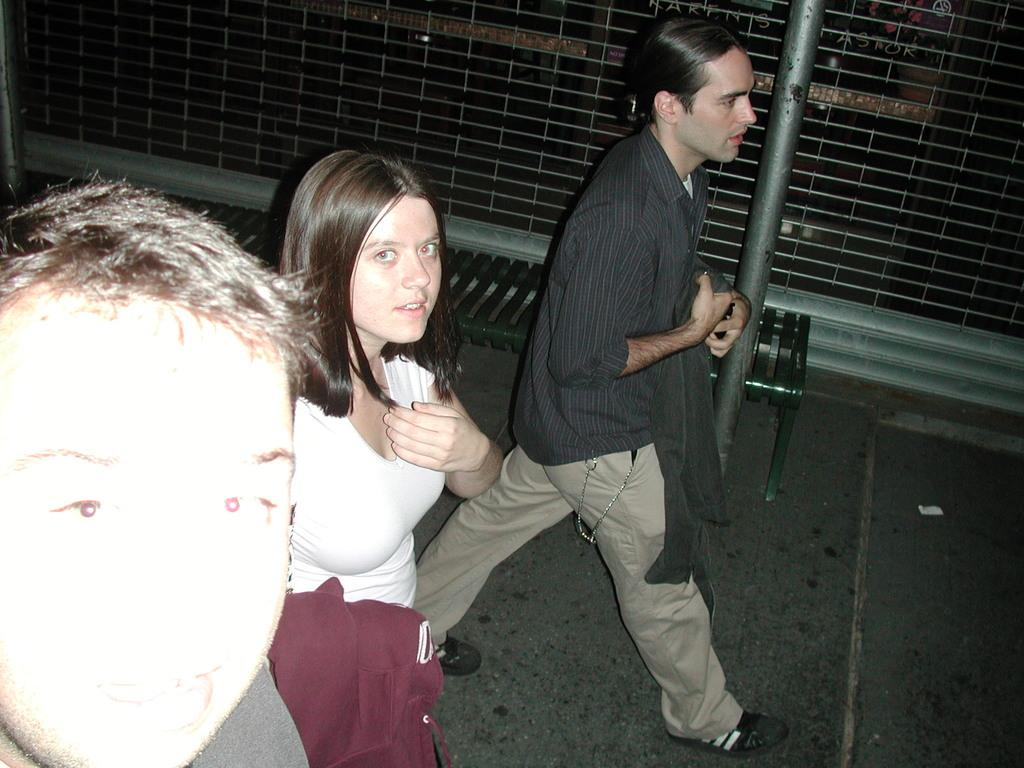What are the people in the image doing? There are persons walking on the road in the image. What can be seen in the background of the image? There is a bench, a pole, and a wall in the background of the image. What flavor of news can be seen on the pole in the image? There is no news or flavor present on the pole in the image; it is simply a pole in the background. 